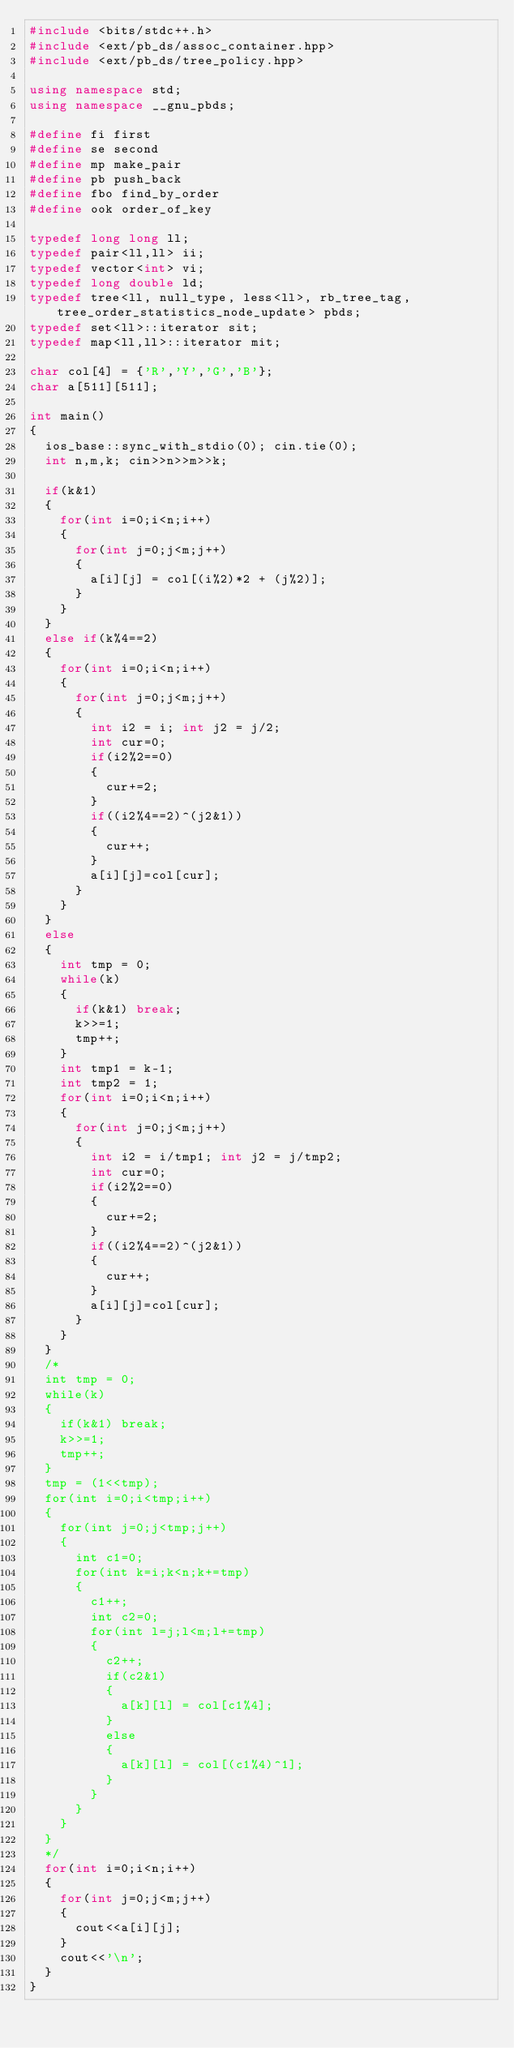<code> <loc_0><loc_0><loc_500><loc_500><_C++_>#include <bits/stdc++.h>
#include <ext/pb_ds/assoc_container.hpp>
#include <ext/pb_ds/tree_policy.hpp>
 
using namespace std;
using namespace __gnu_pbds;
 
#define fi first
#define se second
#define mp make_pair
#define pb push_back
#define fbo find_by_order
#define ook order_of_key
 
typedef long long ll;
typedef pair<ll,ll> ii;
typedef vector<int> vi;
typedef long double ld; 
typedef tree<ll, null_type, less<ll>, rb_tree_tag, tree_order_statistics_node_update> pbds;
typedef set<ll>::iterator sit;
typedef map<ll,ll>::iterator mit;

char col[4] = {'R','Y','G','B'};
char a[511][511];

int main()
{
	ios_base::sync_with_stdio(0); cin.tie(0);
	int n,m,k; cin>>n>>m>>k;
	
	if(k&1)
	{
		for(int i=0;i<n;i++)
		{
			for(int j=0;j<m;j++)
			{
				a[i][j] = col[(i%2)*2 + (j%2)];
			}
		}
	}
	else if(k%4==2)
	{
		for(int i=0;i<n;i++)
		{
			for(int j=0;j<m;j++)
			{
				int i2 = i; int j2 = j/2;
				int cur=0;
				if(i2%2==0)
				{
					cur+=2;
				}
				if((i2%4==2)^(j2&1))
				{
					cur++;
				}
				a[i][j]=col[cur];
			}
		}
	}
	else
	{
		int tmp = 0;
		while(k)
		{
			if(k&1) break;
			k>>=1;
			tmp++;
		}
		int tmp1 = k-1;
		int tmp2 = 1;
		for(int i=0;i<n;i++)
		{
			for(int j=0;j<m;j++)
			{
				int i2 = i/tmp1; int j2 = j/tmp2;
				int cur=0;
				if(i2%2==0)
				{
					cur+=2;
				}
				if((i2%4==2)^(j2&1))
				{
					cur++;
				}
				a[i][j]=col[cur];
			}
		}
	}
	/*
	int tmp = 0;
	while(k)
	{
		if(k&1) break;
		k>>=1;
		tmp++;
	}
	tmp = (1<<tmp);
	for(int i=0;i<tmp;i++)
	{
		for(int j=0;j<tmp;j++)
		{
			int c1=0;
			for(int k=i;k<n;k+=tmp)
			{
				c1++;
				int c2=0;
				for(int l=j;l<m;l+=tmp)
				{
					c2++;
					if(c2&1)
					{
						a[k][l] = col[c1%4];
					}
					else
					{
						a[k][l] = col[(c1%4)^1];
					}
				}
			}
		}
	}
	*/
	for(int i=0;i<n;i++)
	{
		for(int j=0;j<m;j++)
		{
			cout<<a[i][j];
		}
		cout<<'\n';
	}
}
</code> 